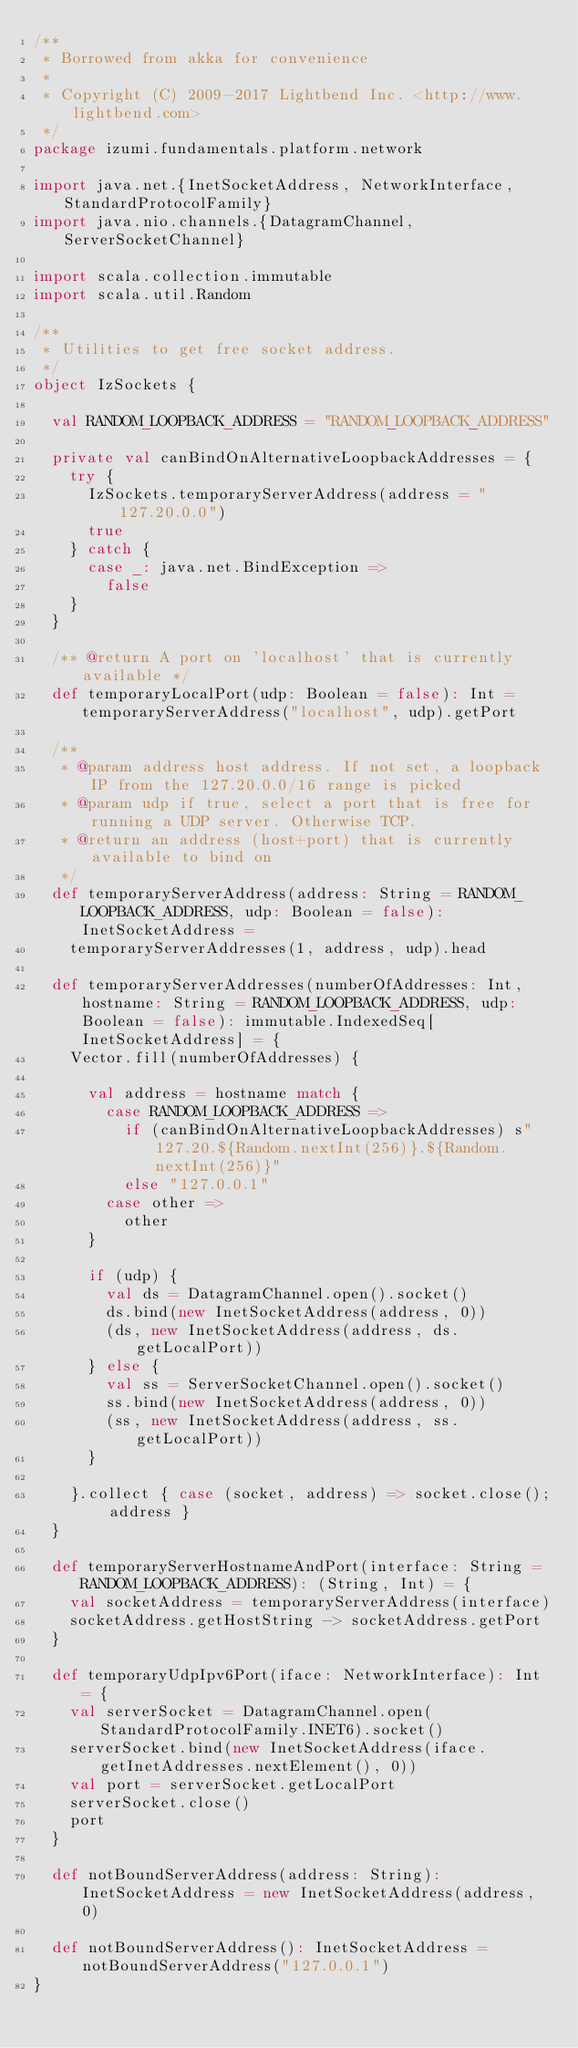Convert code to text. <code><loc_0><loc_0><loc_500><loc_500><_Scala_>/**
 * Borrowed from akka for convenience
 *
 * Copyright (C) 2009-2017 Lightbend Inc. <http://www.lightbend.com>
 */
package izumi.fundamentals.platform.network

import java.net.{InetSocketAddress, NetworkInterface, StandardProtocolFamily}
import java.nio.channels.{DatagramChannel, ServerSocketChannel}

import scala.collection.immutable
import scala.util.Random

/**
 * Utilities to get free socket address.
 */
object IzSockets {

  val RANDOM_LOOPBACK_ADDRESS = "RANDOM_LOOPBACK_ADDRESS"

  private val canBindOnAlternativeLoopbackAddresses = {
    try {
      IzSockets.temporaryServerAddress(address = "127.20.0.0")
      true
    } catch {
      case _: java.net.BindException =>
        false
    }
  }

  /** @return A port on 'localhost' that is currently available */
  def temporaryLocalPort(udp: Boolean = false): Int = temporaryServerAddress("localhost", udp).getPort

  /**
   * @param address host address. If not set, a loopback IP from the 127.20.0.0/16 range is picked
   * @param udp if true, select a port that is free for running a UDP server. Otherwise TCP.
   * @return an address (host+port) that is currently available to bind on
   */
  def temporaryServerAddress(address: String = RANDOM_LOOPBACK_ADDRESS, udp: Boolean = false): InetSocketAddress =
    temporaryServerAddresses(1, address, udp).head

  def temporaryServerAddresses(numberOfAddresses: Int, hostname: String = RANDOM_LOOPBACK_ADDRESS, udp: Boolean = false): immutable.IndexedSeq[InetSocketAddress] = {
    Vector.fill(numberOfAddresses) {

      val address = hostname match {
        case RANDOM_LOOPBACK_ADDRESS =>
          if (canBindOnAlternativeLoopbackAddresses) s"127.20.${Random.nextInt(256)}.${Random.nextInt(256)}"
          else "127.0.0.1"
        case other =>
          other
      }

      if (udp) {
        val ds = DatagramChannel.open().socket()
        ds.bind(new InetSocketAddress(address, 0))
        (ds, new InetSocketAddress(address, ds.getLocalPort))
      } else {
        val ss = ServerSocketChannel.open().socket()
        ss.bind(new InetSocketAddress(address, 0))
        (ss, new InetSocketAddress(address, ss.getLocalPort))
      }

    }.collect { case (socket, address) => socket.close(); address }
  }

  def temporaryServerHostnameAndPort(interface: String = RANDOM_LOOPBACK_ADDRESS): (String, Int) = {
    val socketAddress = temporaryServerAddress(interface)
    socketAddress.getHostString -> socketAddress.getPort
  }

  def temporaryUdpIpv6Port(iface: NetworkInterface): Int = {
    val serverSocket = DatagramChannel.open(StandardProtocolFamily.INET6).socket()
    serverSocket.bind(new InetSocketAddress(iface.getInetAddresses.nextElement(), 0))
    val port = serverSocket.getLocalPort
    serverSocket.close()
    port
  }

  def notBoundServerAddress(address: String): InetSocketAddress = new InetSocketAddress(address, 0)

  def notBoundServerAddress(): InetSocketAddress = notBoundServerAddress("127.0.0.1")
}
</code> 